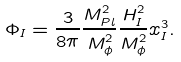Convert formula to latex. <formula><loc_0><loc_0><loc_500><loc_500>\Phi _ { I } = \frac { 3 } { 8 \pi } \frac { M _ { P l } ^ { 2 } } { M _ { \phi } ^ { 2 } } \frac { H _ { I } ^ { 2 } } { M _ { \phi } ^ { 2 } } x _ { I } ^ { 3 } .</formula> 